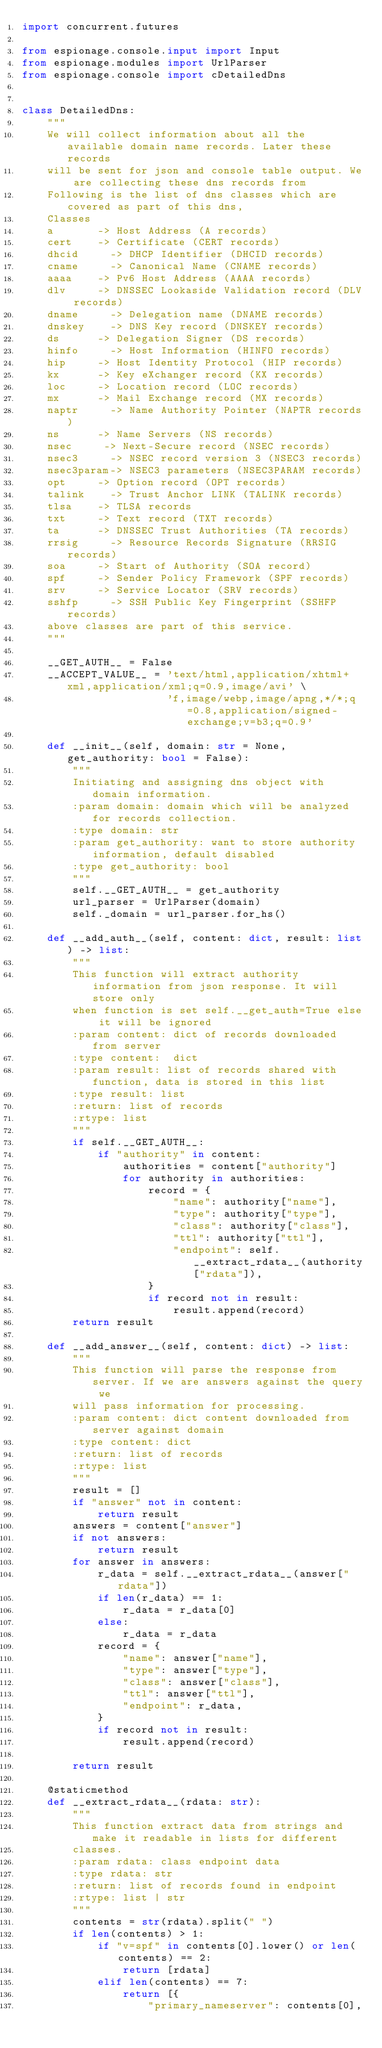<code> <loc_0><loc_0><loc_500><loc_500><_Python_>import concurrent.futures

from espionage.console.input import Input
from espionage.modules import UrlParser
from espionage.console import cDetailedDns


class DetailedDns:
    """
    We will collect information about all the available domain name records. Later these records
    will be sent for json and console table output. We are collecting these dns records from 
    Following is the list of dns classes which are covered as part of this dns,
    Classes
    a       -> Host Address (A records)
    cert    -> Certificate (CERT records)
    dhcid     -> DHCP Identifier (DHCID records)
    cname     -> Canonical Name (CNAME records)
    aaaa    -> Pv6 Host Address (AAAA records)
    dlv     -> DNSSEC Lookaside Validation record (DLV records)
    dname     -> Delegation name (DNAME records)
    dnskey    -> DNS Key record (DNSKEY records)
    ds      -> Delegation Signer (DS records)
    hinfo     -> Host Information (HINFO records)
    hip     -> Host Identity Protocol (HIP records)
    kx      -> Key eXchanger record (KX records)
    loc     -> Location record (LOC records)
    mx      -> Mail Exchange record (MX records)
    naptr     -> Name Authority Pointer (NAPTR records)
    ns      -> Name Servers (NS records)
    nsec     -> Next-Secure record (NSEC records)
    nsec3     -> NSEC record version 3 (NSEC3 records)
    nsec3param-> NSEC3 parameters (NSEC3PARAM records)
    opt     -> Option record (OPT records)
    talink    -> Trust Anchor LINK (TALINK records)
    tlsa    -> TLSA records
    txt     -> Text record (TXT records)
    ta      -> DNSSEC Trust Authorities (TA records)
    rrsig     -> Resource Records Signature (RRSIG records)
    soa     -> Start of Authority (SOA record)
    spf     -> Sender Policy Framework (SPF records)
    srv     -> Service Locator (SRV records)
    sshfp     -> SSH Public Key Fingerprint (SSHFP records)
    above classes are part of this service.
    """

    __GET_AUTH__ = False
    __ACCEPT_VALUE__ = 'text/html,application/xhtml+xml,application/xml;q=0.9,image/avi' \
                       'f,image/webp,image/apng,*/*;q=0.8,application/signed-exchange;v=b3;q=0.9'

    def __init__(self, domain: str = None, get_authority: bool = False):
        """
        Initiating and assigning dns object with domain information.
        :param domain: domain which will be analyzed for records collection.
        :type domain: str
        :param get_authority: want to store authority information, default disabled
        :type get_authority: bool
        """
        self.__GET_AUTH__ = get_authority
        url_parser = UrlParser(domain)
        self._domain = url_parser.for_hs()

    def __add_auth__(self, content: dict, result: list) -> list:
        """
        This function will extract authority information from json response. It will store only 
        when function is set self.__get_auth=True else it will be ignored
        :param content: dict of records downloaded from server
        :type content:  dict
        :param result: list of records shared with function, data is stored in this list
        :type result: list
        :return: list of records
        :rtype: list
        """
        if self.__GET_AUTH__:
            if "authority" in content:
                authorities = content["authority"]
                for authority in authorities:
                    record = {
                        "name": authority["name"],
                        "type": authority["type"],
                        "class": authority["class"],
                        "ttl": authority["ttl"],
                        "endpoint": self.__extract_rdata__(authority["rdata"]),
                    }
                    if record not in result:
                        result.append(record)
        return result

    def __add_answer__(self, content: dict) -> list:
        """
        This function will parse the response from server. If we are answers against the query we 
        will pass information for processing.
        :param content: dict content downloaded from server against domain
        :type content: dict
        :return: list of records
        :rtype: list
        """
        result = []
        if "answer" not in content:
            return result
        answers = content["answer"]
        if not answers:
            return result
        for answer in answers:
            r_data = self.__extract_rdata__(answer["rdata"])
            if len(r_data) == 1:
                r_data = r_data[0]
            else:
                r_data = r_data
            record = {
                "name": answer["name"],
                "type": answer["type"],
                "class": answer["class"],
                "ttl": answer["ttl"],
                "endpoint": r_data,
            }
            if record not in result:
                result.append(record)

        return result

    @staticmethod
    def __extract_rdata__(rdata: str):
        """
        This function extract data from strings and make it readable in lists for different 
        classes.
        :param rdata: class endpoint data
        :type rdata: str
        :return: list of records found in endpoint
        :rtype: list | str
        """
        contents = str(rdata).split(" ")
        if len(contents) > 1:
            if "v=spf" in contents[0].lower() or len(contents) == 2:
                return [rdata]
            elif len(contents) == 7:
                return [{
                    "primary_nameserver": contents[0],</code> 